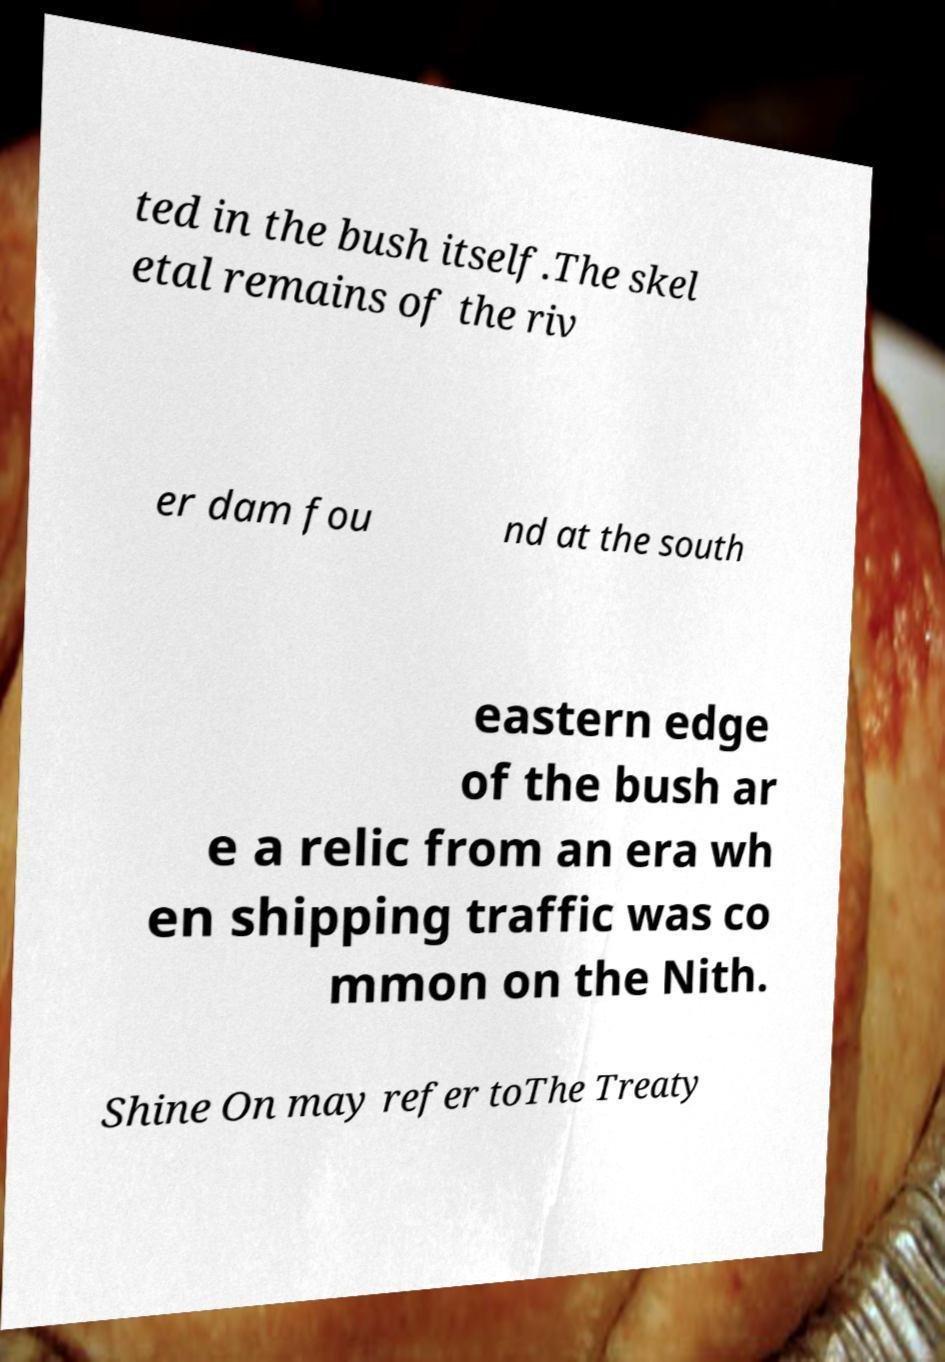For documentation purposes, I need the text within this image transcribed. Could you provide that? ted in the bush itself.The skel etal remains of the riv er dam fou nd at the south eastern edge of the bush ar e a relic from an era wh en shipping traffic was co mmon on the Nith. Shine On may refer toThe Treaty 